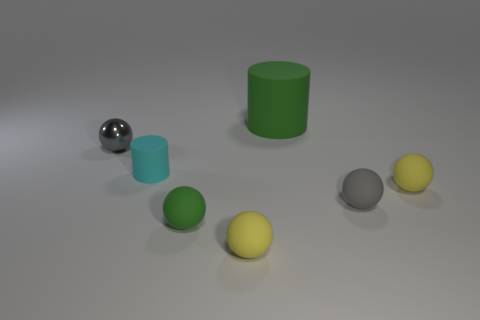Are the small object behind the cyan rubber object and the small green sphere made of the same material?
Ensure brevity in your answer.  No. What material is the gray sphere behind the small yellow sphere on the right side of the yellow matte object in front of the small green object made of?
Keep it short and to the point. Metal. What number of other things are the same shape as the large green object?
Your response must be concise. 1. What color is the ball left of the tiny cyan cylinder?
Ensure brevity in your answer.  Gray. What number of gray spheres are behind the big thing behind the gray sphere that is right of the metallic thing?
Provide a short and direct response. 0. There is a small yellow rubber sphere in front of the green ball; what number of small gray objects are right of it?
Make the answer very short. 1. There is a cyan cylinder; how many small matte cylinders are behind it?
Your answer should be very brief. 0. How many other things are there of the same size as the gray metallic sphere?
Your answer should be very brief. 5. There is a green object that is the same shape as the gray matte thing; what size is it?
Offer a very short reply. Small. What shape is the tiny yellow rubber object on the left side of the gray rubber thing?
Provide a short and direct response. Sphere. 